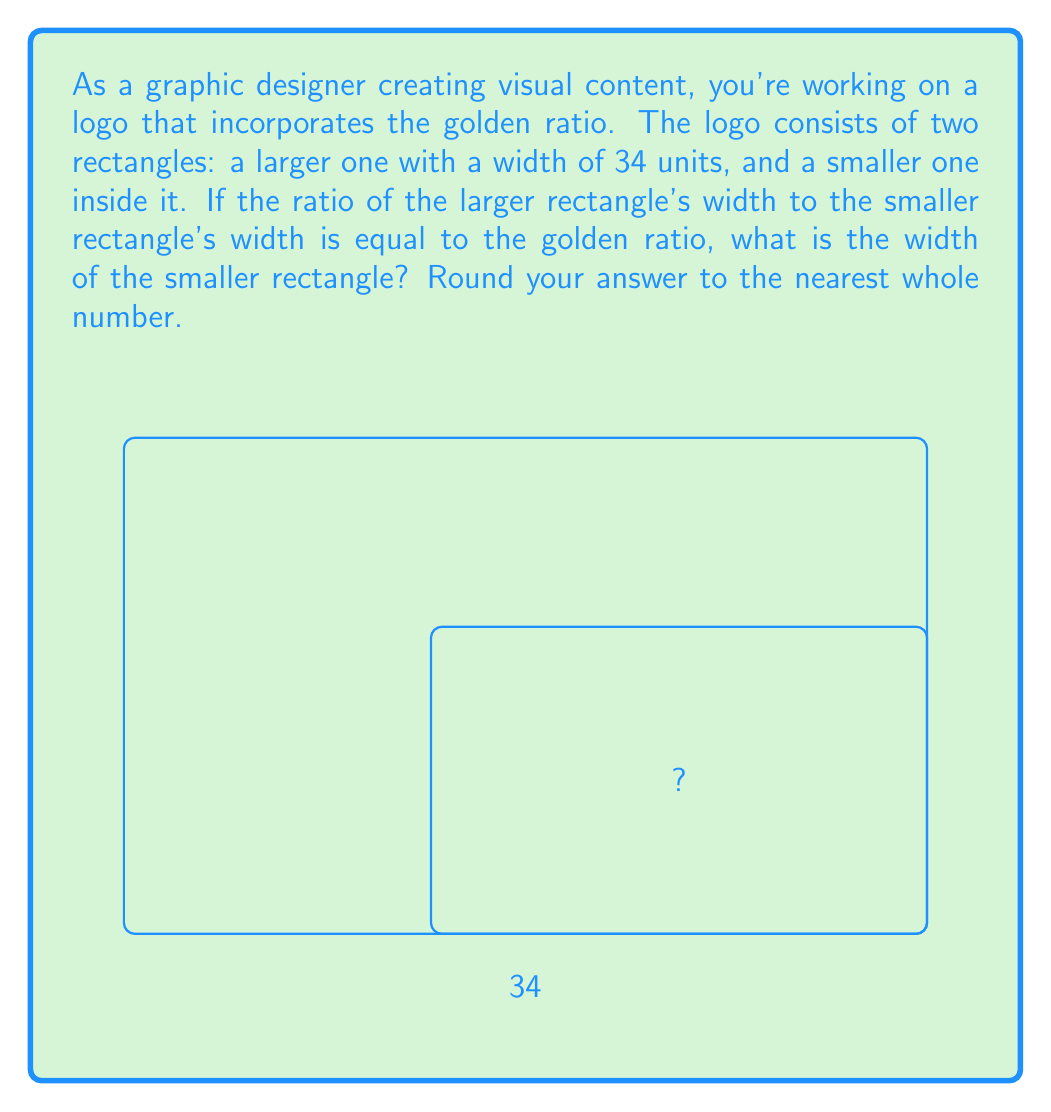Teach me how to tackle this problem. Let's approach this step-by-step:

1) The golden ratio, often denoted by φ (phi), is approximately equal to 1.618033988749895.

2) Let x be the width of the smaller rectangle. We can set up the following equation:

   $$\frac{34}{x} = \phi$$

3) We can solve this equation for x:

   $$x = \frac{34}{\phi}$$

4) Substituting the value of φ:

   $$x = \frac{34}{1.618033988749895}$$

5) Using a calculator or computer:

   $$x ≈ 21.01281539374603$$

6) Rounding to the nearest whole number:

   $$x ≈ 21$$

Therefore, the width of the smaller rectangle is approximately 21 units.
Answer: 21 units 